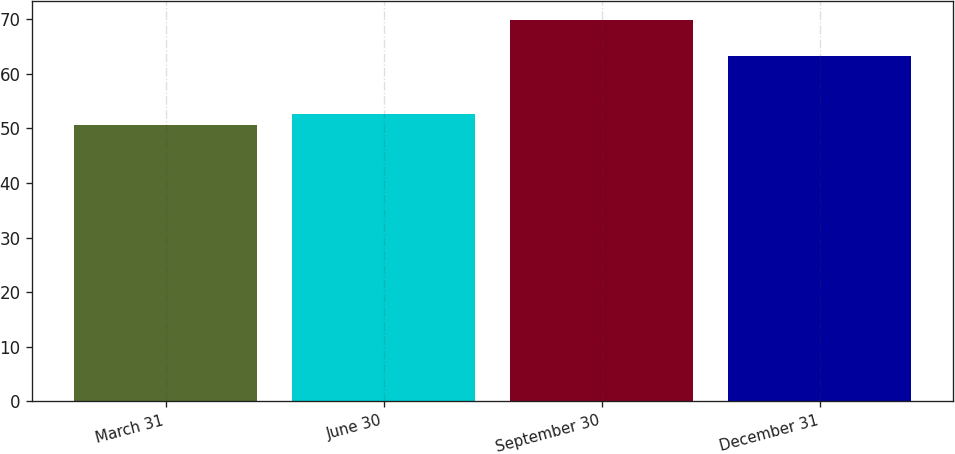<chart> <loc_0><loc_0><loc_500><loc_500><bar_chart><fcel>March 31<fcel>June 30<fcel>September 30<fcel>December 31<nl><fcel>50.68<fcel>52.6<fcel>69.9<fcel>63.26<nl></chart> 